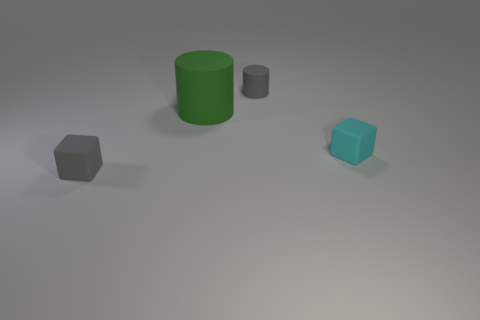Subtract all cyan blocks. How many blocks are left? 1 Add 4 tiny green metallic blocks. How many objects exist? 8 Add 4 cyan rubber blocks. How many cyan rubber blocks are left? 5 Add 3 tiny matte blocks. How many tiny matte blocks exist? 5 Subtract 0 red cylinders. How many objects are left? 4 Subtract all small matte things. Subtract all small gray cylinders. How many objects are left? 0 